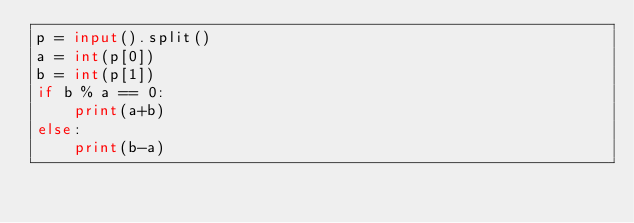Convert code to text. <code><loc_0><loc_0><loc_500><loc_500><_Python_>p = input().split()
a = int(p[0])
b = int(p[1])
if b % a == 0:
    print(a+b)
else:
    print(b-a)</code> 